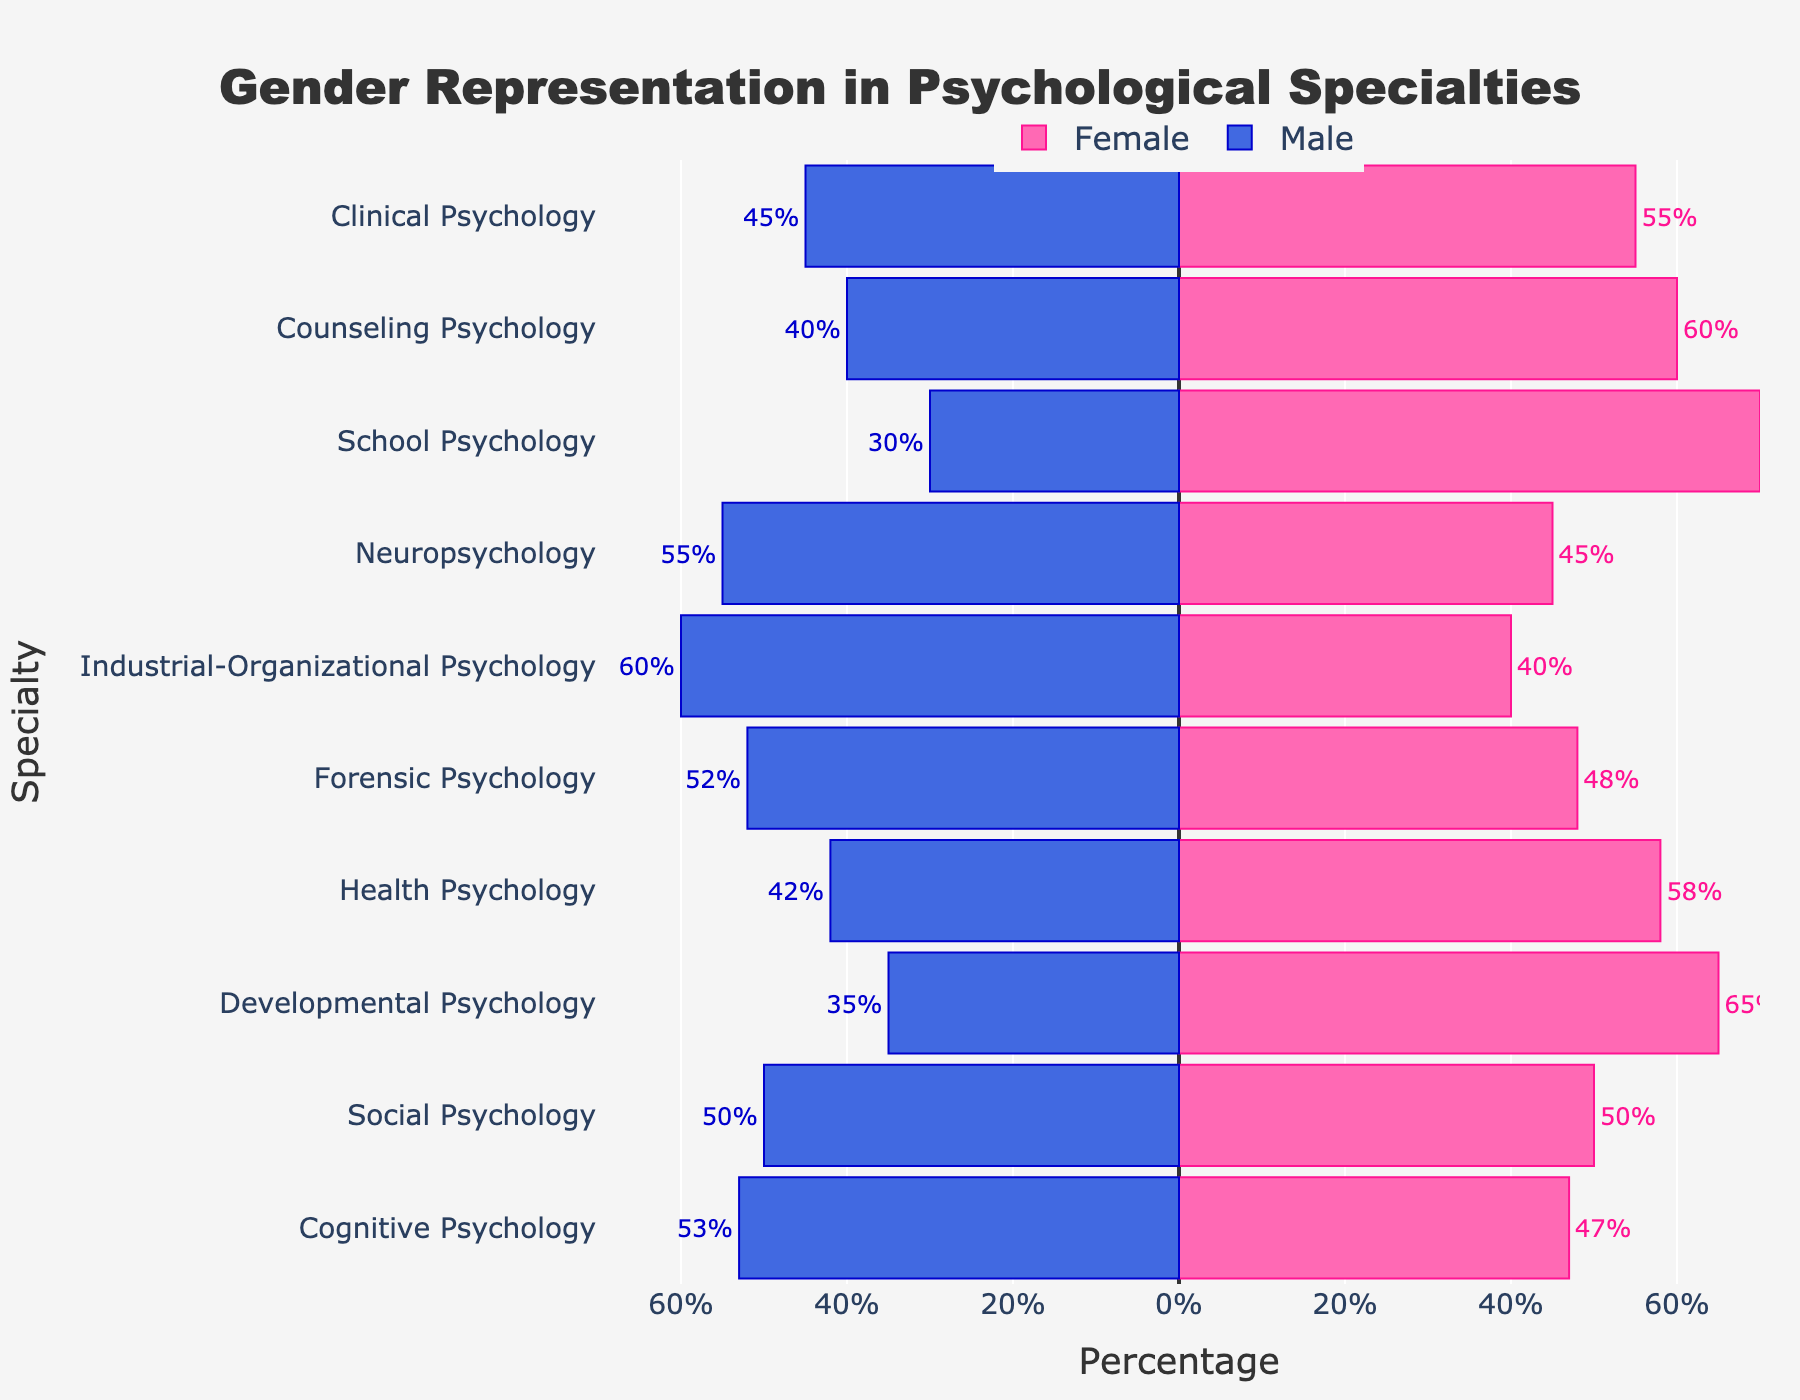What's the title of the figure? The title is located at the top of the figure, centered and written in large font. It provides a summary of what the figure is about.
Answer: Gender Representation in Psychological Specialties Which specialty has the highest percentage of female professionals? To determine this, look at the lengths of the pink bars on the positive (right) side. The longest pink bar represents the specialty with the highest female percentage.
Answer: School Psychology Which specialty shows an equal representation of male and female professionals? Look for the specialty where the lengths of the pink and blue bars are the same, indicating equal percentages.
Answer: Social Psychology How many specialties have more than 60% female representation? Count the number of pink bars that extend beyond the 60% mark on the positive side of the x-axis.
Answer: 2 What's the difference in female representation between Clinical Psychology and Neuropsychology? Find the lengths of the pink bars for both Clinical Psychology and Neuropsychology, then subtract the percentage of Neuropsychology from Clinical Psychology.
Answer: 10% Which specialties have a higher percentage of male professionals compared to female? Identify the specialties where the blue bars (negative side) are longer than the pink bars (positive side).
Answer: Neuropsychology, Industrial-Organizational Psychology, Forensic Psychology, Cognitive Psychology What is the average percentage of female professionals across all specialties? Add up the percentages of female professionals for all specialties and divide by the number of specialties (10). Calculation: (55 + 60 + 70 + 45 + 40 + 48 + 58 + 65 + 50 + 47) / 10
Answer: 53.8% Which specialty has the smallest gender disparity? Find the specialty where the difference between male and female percentages is the smallest. This can be observed by comparing the lengths of the bars.
Answer: Social Psychology What is the difference in male representation between Industrial-Organizational Psychology and Health Psychology? Look at the lengths of the blue bars for Industrial-Organizational Psychology and Health Psychology. Subtract the percentage of Health Psychology from Industrial-Organizational Psychology.
Answer: 18% How many specialties have more male professionals than females? Count the number of specialties where the blue bars are longer than the pink bars.
Answer: 4 If you combined the percentages of female professionals in Clinical Psychology and Counseling Psychology, what would the total percentage be? Add the percentages of female professionals in Clinical Psychology and Counseling Psychology. Calculation: 55 + 60
Answer: 115% 